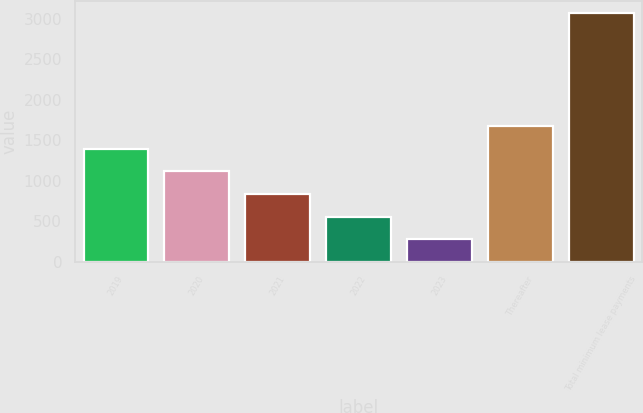Convert chart to OTSL. <chart><loc_0><loc_0><loc_500><loc_500><bar_chart><fcel>2019<fcel>2020<fcel>2021<fcel>2022<fcel>2023<fcel>Thereafter<fcel>Total minimum lease payments<nl><fcel>1395<fcel>1115.5<fcel>836<fcel>556.5<fcel>277<fcel>1674.5<fcel>3072<nl></chart> 